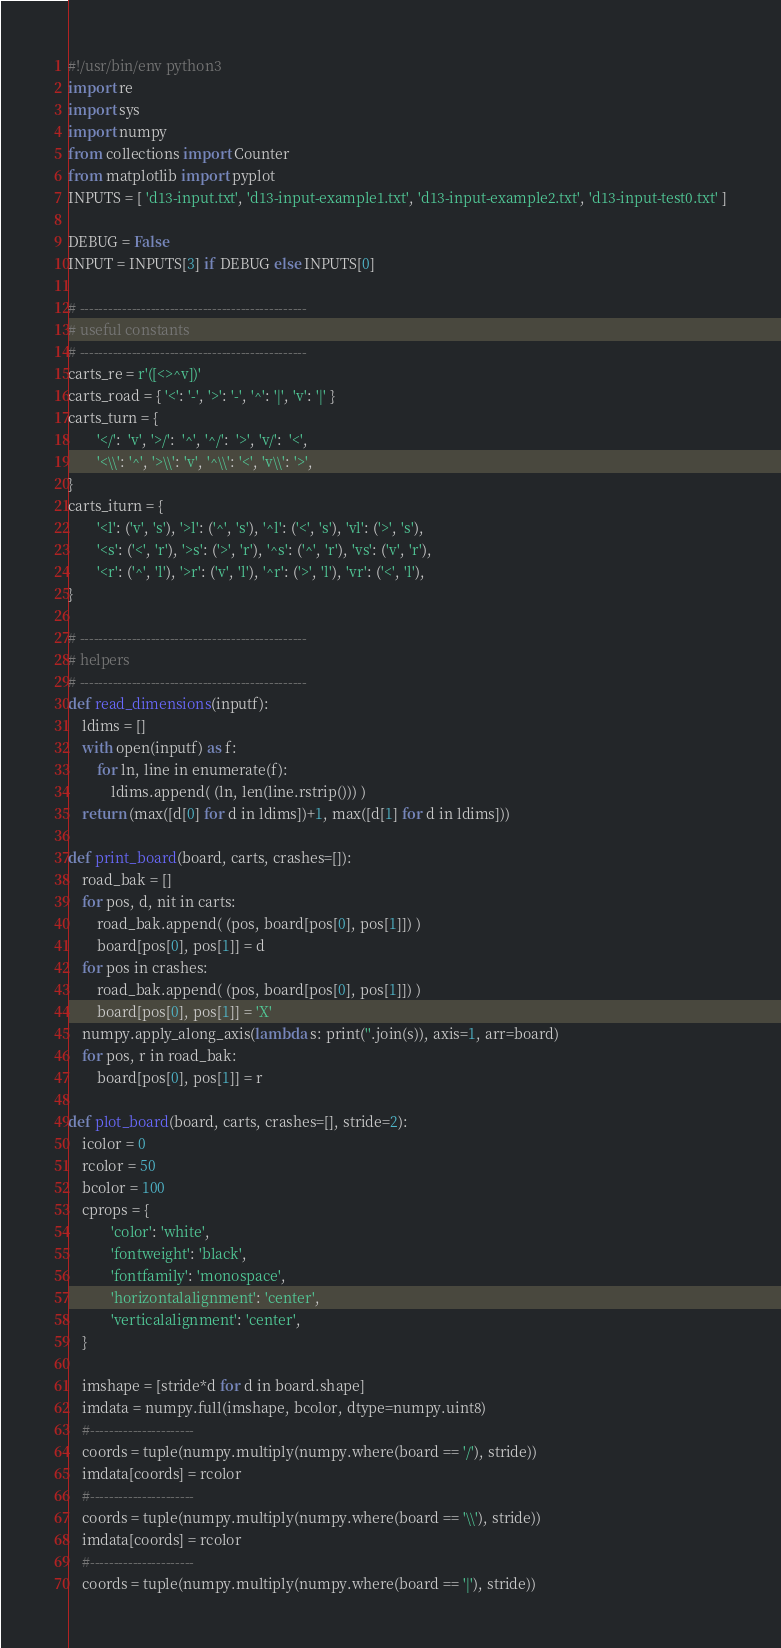<code> <loc_0><loc_0><loc_500><loc_500><_Python_>#!/usr/bin/env python3
import re
import sys
import numpy
from collections import Counter
from matplotlib import pyplot
INPUTS = [ 'd13-input.txt', 'd13-input-example1.txt', 'd13-input-example2.txt', 'd13-input-test0.txt' ]

DEBUG = False
INPUT = INPUTS[3] if DEBUG else INPUTS[0]

# ------------------------------------------------
# useful constants
# ------------------------------------------------
carts_re = r'([<>^v])'
carts_road = { '<': '-', '>': '-', '^': '|', 'v': '|' }
carts_turn = {
        '</':  'v', '>/':  '^', '^/':  '>', 'v/':  '<',
        '<\\': '^', '>\\': 'v', '^\\': '<', 'v\\': '>',
}
carts_iturn = {
        '<l': ('v', 's'), '>l': ('^', 's'), '^l': ('<', 's'), 'vl': ('>', 's'),
        '<s': ('<', 'r'), '>s': ('>', 'r'), '^s': ('^', 'r'), 'vs': ('v', 'r'),
        '<r': ('^', 'l'), '>r': ('v', 'l'), '^r': ('>', 'l'), 'vr': ('<', 'l'),
}

# ------------------------------------------------
# helpers
# ------------------------------------------------
def read_dimensions(inputf):
    ldims = []
    with open(inputf) as f:
        for ln, line in enumerate(f):
            ldims.append( (ln, len(line.rstrip())) )
    return (max([d[0] for d in ldims])+1, max([d[1] for d in ldims]))

def print_board(board, carts, crashes=[]):
    road_bak = []
    for pos, d, nit in carts:
        road_bak.append( (pos, board[pos[0], pos[1]]) )
        board[pos[0], pos[1]] = d
    for pos in crashes:
        road_bak.append( (pos, board[pos[0], pos[1]]) )
        board[pos[0], pos[1]] = 'X'
    numpy.apply_along_axis(lambda s: print(''.join(s)), axis=1, arr=board)
    for pos, r in road_bak:
        board[pos[0], pos[1]] = r

def plot_board(board, carts, crashes=[], stride=2):
    icolor = 0
    rcolor = 50
    bcolor = 100
    cprops = {
            'color': 'white',
            'fontweight': 'black',
            'fontfamily': 'monospace',
            'horizontalalignment': 'center',
            'verticalalignment': 'center',
    }

    imshape = [stride*d for d in board.shape]
    imdata = numpy.full(imshape, bcolor, dtype=numpy.uint8)
    #----------------------
    coords = tuple(numpy.multiply(numpy.where(board == '/'), stride))
    imdata[coords] = rcolor
    #----------------------
    coords = tuple(numpy.multiply(numpy.where(board == '\\'), stride))
    imdata[coords] = rcolor
    #----------------------
    coords = tuple(numpy.multiply(numpy.where(board == '|'), stride))</code> 